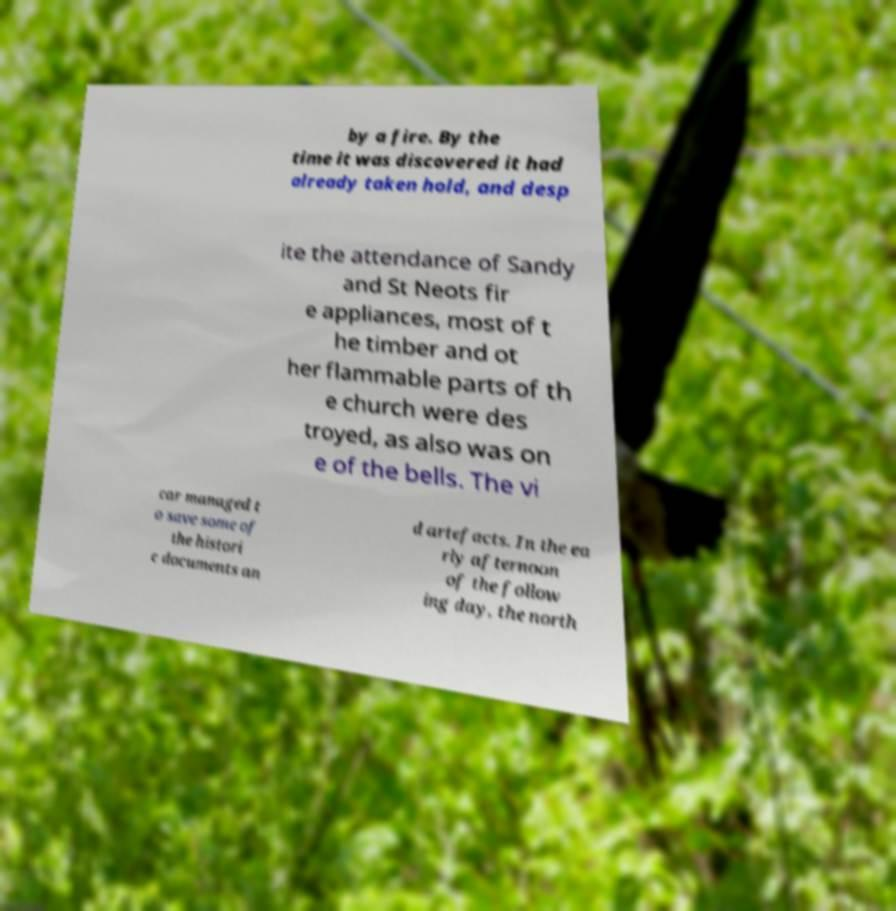There's text embedded in this image that I need extracted. Can you transcribe it verbatim? by a fire. By the time it was discovered it had already taken hold, and desp ite the attendance of Sandy and St Neots fir e appliances, most of t he timber and ot her flammable parts of th e church were des troyed, as also was on e of the bells. The vi car managed t o save some of the histori c documents an d artefacts. In the ea rly afternoon of the follow ing day, the north 